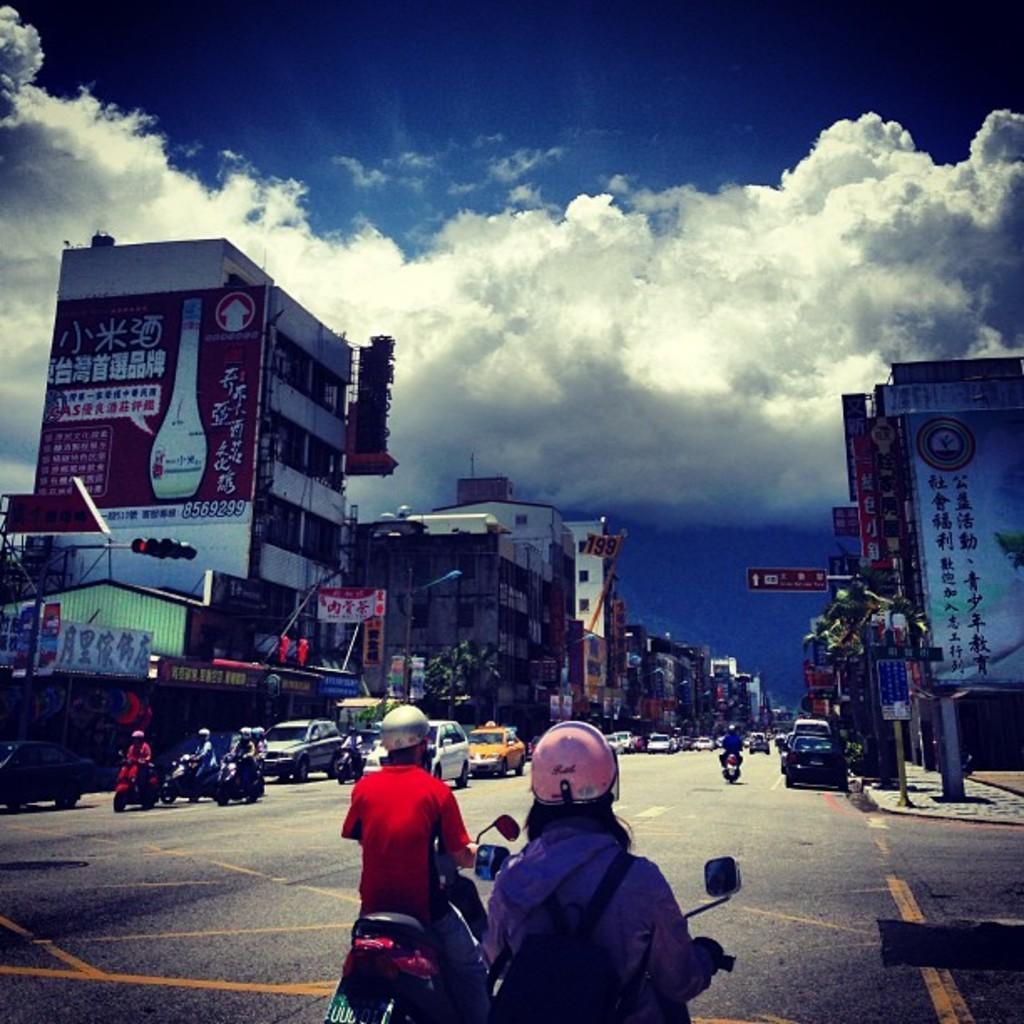How would you summarize this image in a sentence or two? In this image I can see people on the vehicles. On the right there is a building. On the left there is a hoarding with some text in it. In the background I can see sky with clouds. 